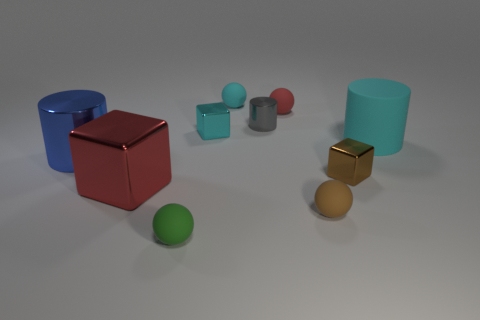Subtract 1 balls. How many balls are left? 3 Subtract all yellow spheres. Subtract all red cubes. How many spheres are left? 4 Subtract all spheres. How many objects are left? 6 Subtract 1 red blocks. How many objects are left? 9 Subtract all purple matte cubes. Subtract all tiny matte things. How many objects are left? 6 Add 3 tiny gray metal cylinders. How many tiny gray metal cylinders are left? 4 Add 4 green matte spheres. How many green matte spheres exist? 5 